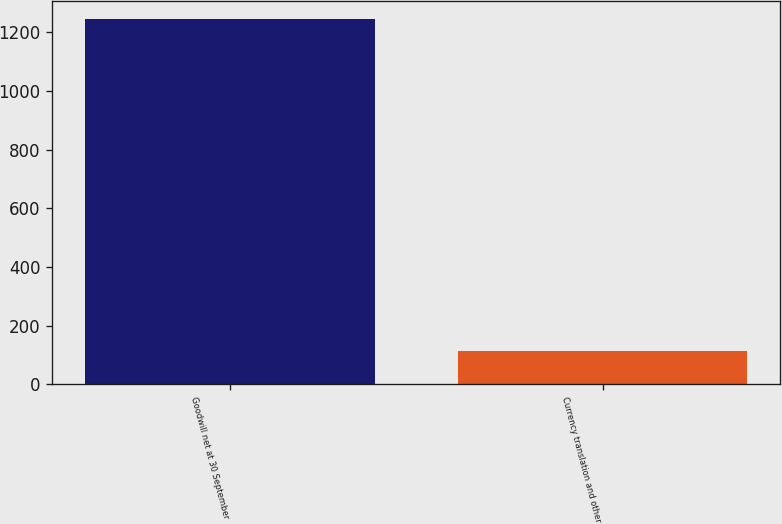<chart> <loc_0><loc_0><loc_500><loc_500><bar_chart><fcel>Goodwill net at 30 September<fcel>Currency translation and other<nl><fcel>1243.89<fcel>111.4<nl></chart> 